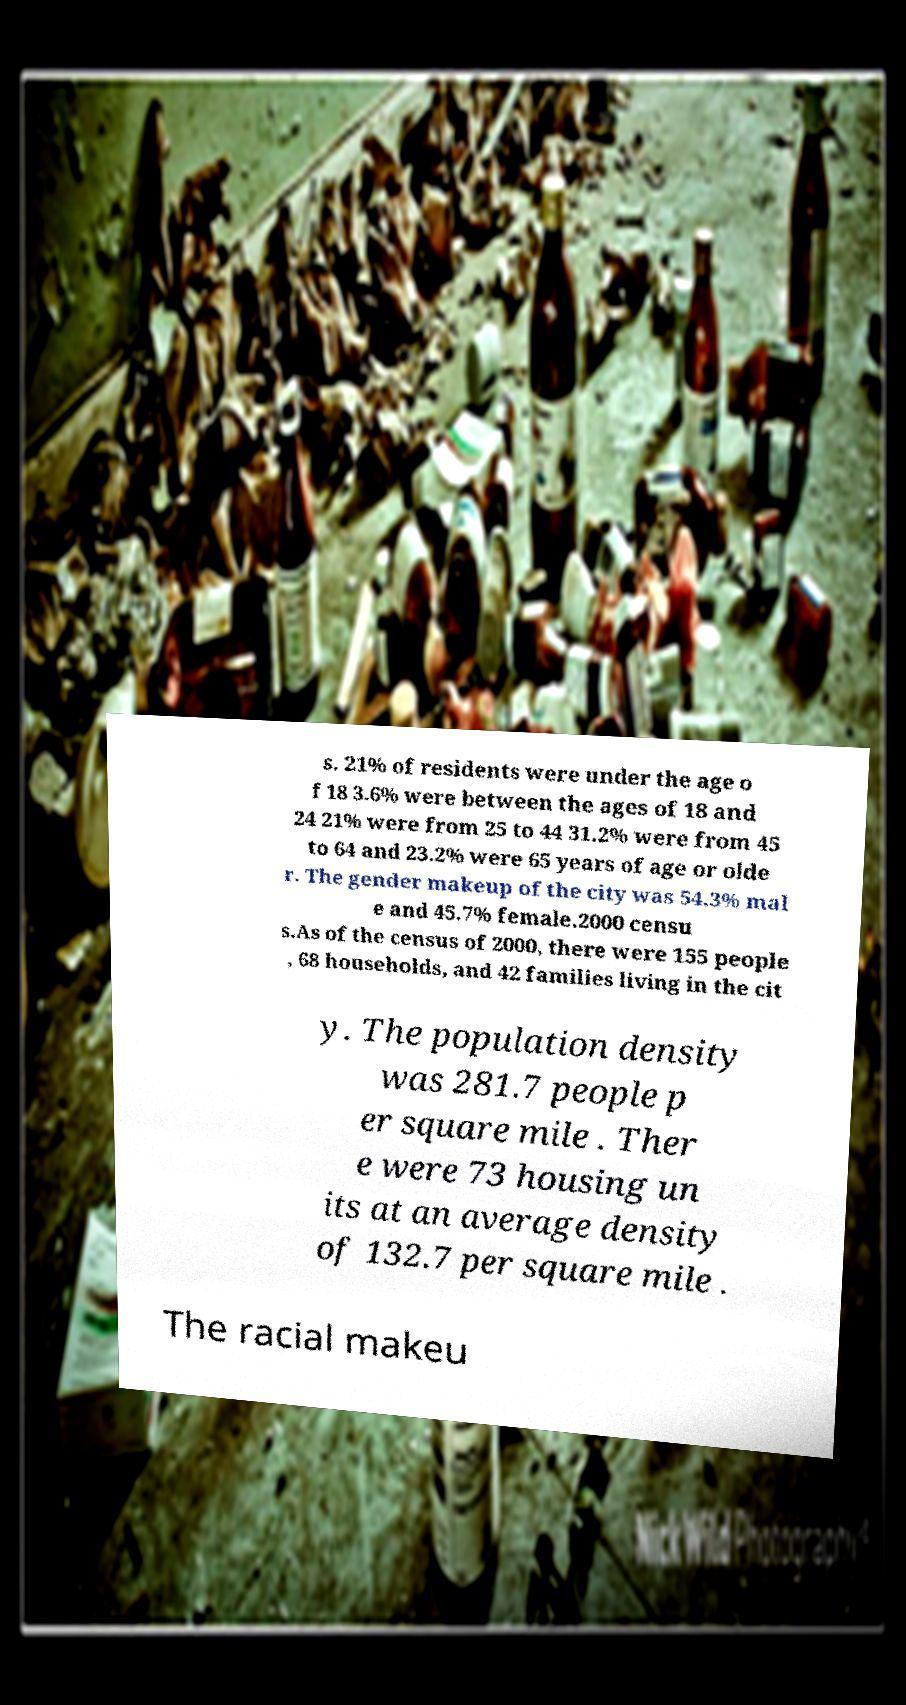What messages or text are displayed in this image? I need them in a readable, typed format. s. 21% of residents were under the age o f 18 3.6% were between the ages of 18 and 24 21% were from 25 to 44 31.2% were from 45 to 64 and 23.2% were 65 years of age or olde r. The gender makeup of the city was 54.3% mal e and 45.7% female.2000 censu s.As of the census of 2000, there were 155 people , 68 households, and 42 families living in the cit y. The population density was 281.7 people p er square mile . Ther e were 73 housing un its at an average density of 132.7 per square mile . The racial makeu 